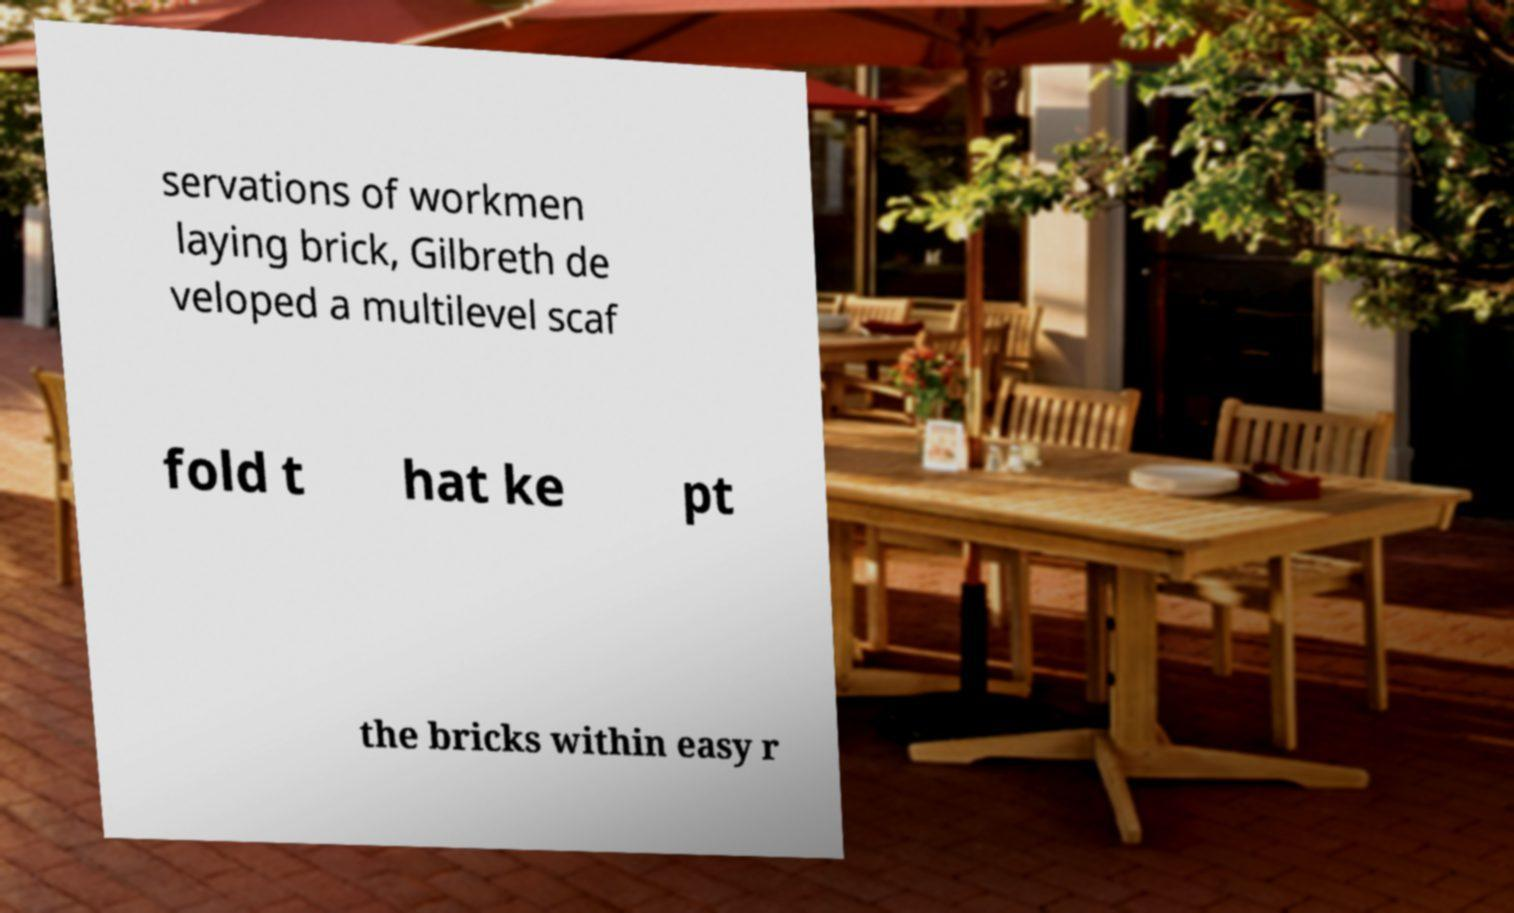For documentation purposes, I need the text within this image transcribed. Could you provide that? servations of workmen laying brick, Gilbreth de veloped a multilevel scaf fold t hat ke pt the bricks within easy r 